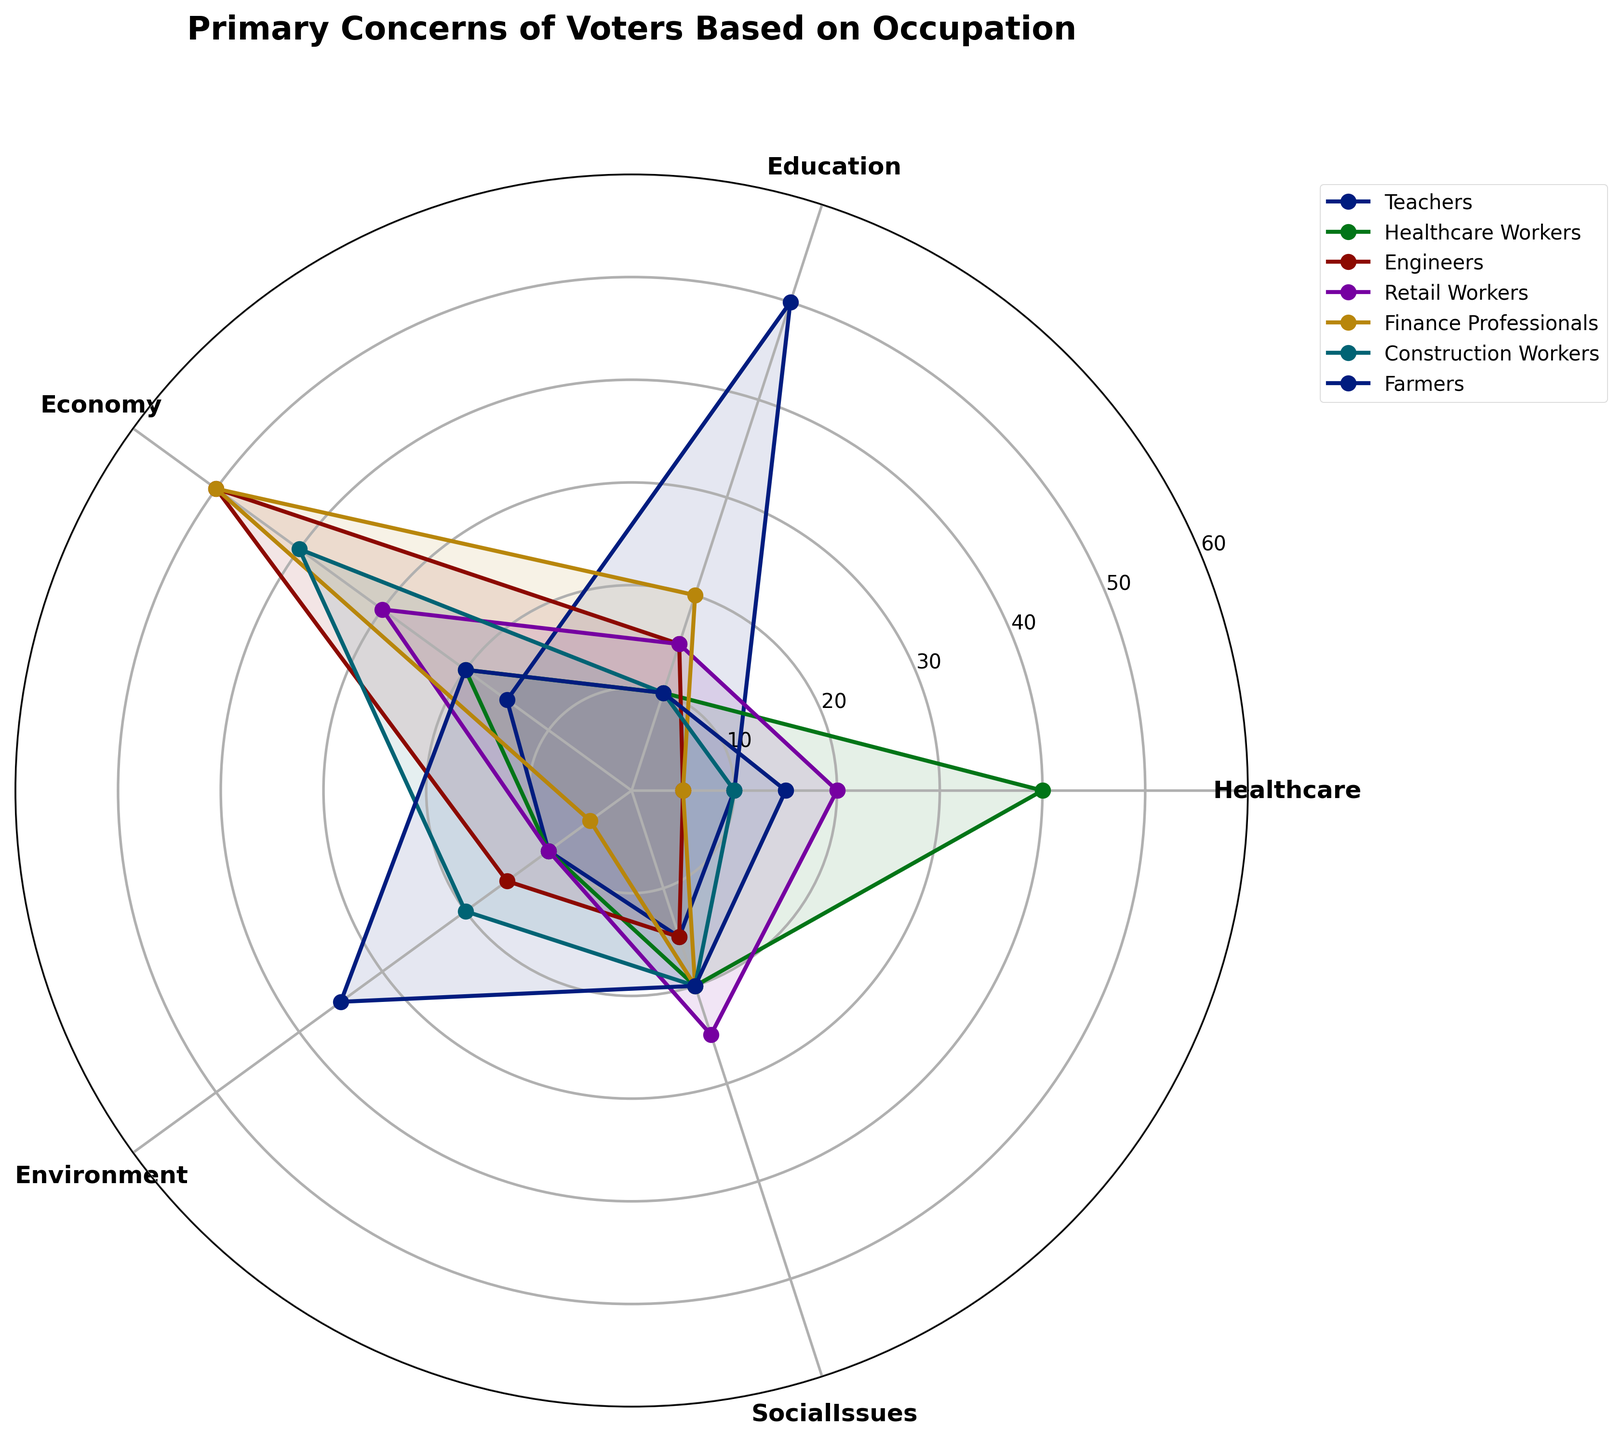What's the title of the chart? The title of a chart is typically found at the top and it summarizes the main topic or focus of the chart. In this case, it would be the heading at the top of the polar chart.
Answer: Primary Concerns of Voters Based on Occupation How many categories are there in the chart, and what are they? Counting the categories involves looking at the labels around the polar chart, which indicate the different concerns.
Answer: There are five categories: Healthcare, Education, Economy, Environment, Social Issues Which occupation has the highest concern for healthcare? To determine this, we look at the 'Healthcare' category and identify which occupation has the highest value on the polar chart.
Answer: Healthcare Workers What is the difference in concern for social issues between Teachers and Retail Workers? First, locate the values for 'Social Issues' for both Teachers and Retail Workers, then subtract the smaller value from the larger one. Teachers value social issues at 15 and Retail Workers at 25, so the difference is 25 - 15.
Answer: 10 Which occupation values the environment the most, and what is their value? To answer this, identify the highest value in the 'Environment' category and see which occupation it belongs to.
Answer: Farmers with a value of 35 Do any occupations have the same level of concern for education? If so, which ones? Compare the values for 'Education' across all occupations. Teachers and Retail Workers have the same value of 15.
Answer: Teachers and Retail Workers Which occupation's primary concern is the economy? Determine this by finding which occupation has the highest value in the 'Economy' category and checking if it's higher than its values in other categories. Engineers and Finance Professionals both have the highest values in the economy category, so they share this concern as primary.
Answer: Engineers and Finance Professionals What's the average level of concern for the healthcare category across all occupations? Add the healthcare values for all occupations and divide by the number of occupations: (10 + 40 + 5 + 20 + 5 + 10 + 15) / 7
Answer: 15 Which occupation has the most evenly distributed concerns across all categories? To answer this, look for the occupation whose values are most balanced or equal for all categories. Retail Workers have concerns distributed as: Healthcare 20, Education 15, Economy 30, Environment 10, Social Issues 25 and this distribution variation is relatively small.
Answer: Retail Workers 